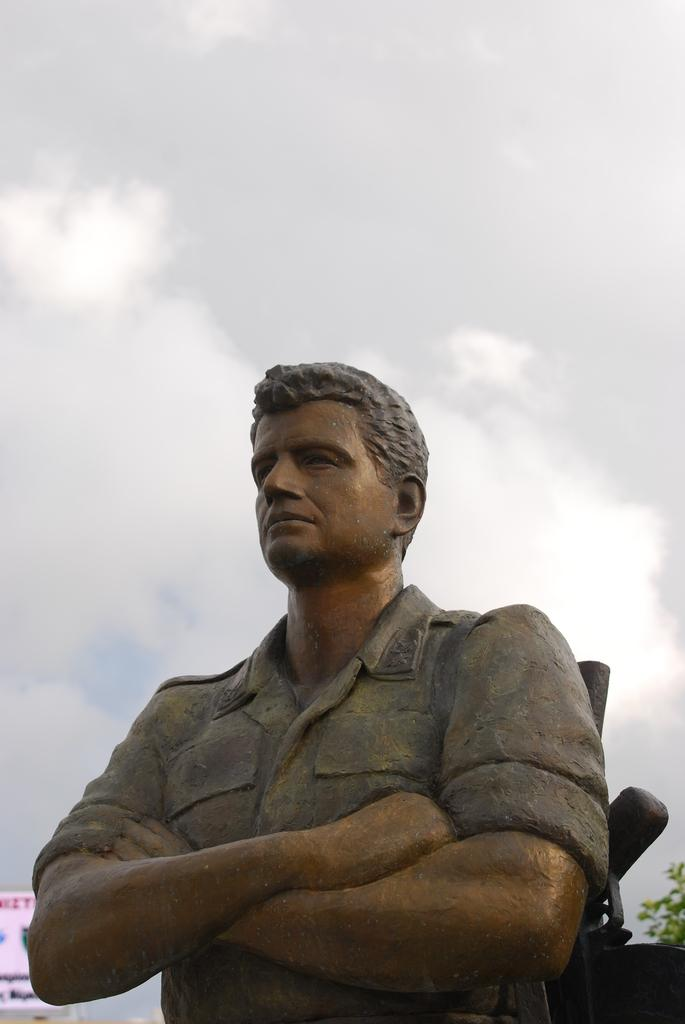What is the main subject of the image? There is a statue of a person in the image. What can be seen in the background of the image? There is a board and a tree in the background of the image. How would you describe the sky in the image? The sky is cloudy in the background of the image. How does the fan help the statue in the image? There is no fan present in the image, so it cannot help the statue. 